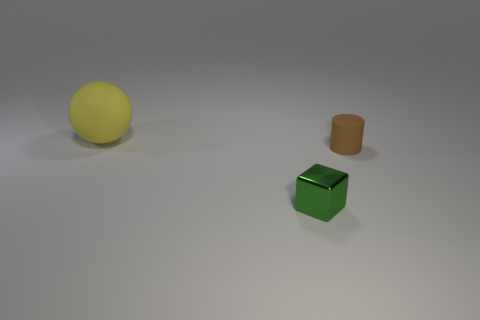Add 3 brown metallic spheres. How many objects exist? 6 Subtract all cylinders. How many objects are left? 2 Add 1 small green shiny blocks. How many small green shiny blocks are left? 2 Add 2 small rubber things. How many small rubber things exist? 3 Subtract 0 gray spheres. How many objects are left? 3 Subtract all tiny purple cubes. Subtract all green metallic blocks. How many objects are left? 2 